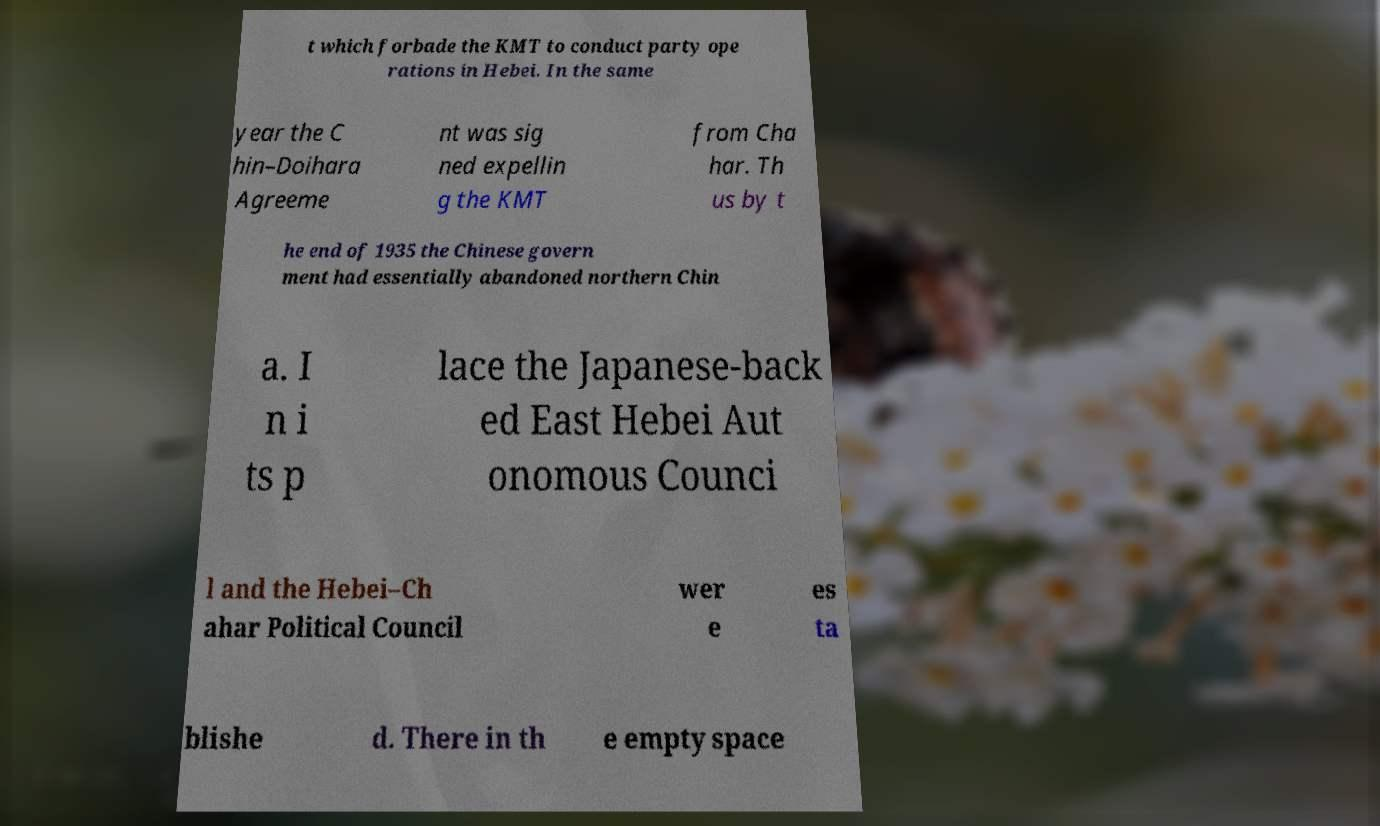Could you assist in decoding the text presented in this image and type it out clearly? t which forbade the KMT to conduct party ope rations in Hebei. In the same year the C hin–Doihara Agreeme nt was sig ned expellin g the KMT from Cha har. Th us by t he end of 1935 the Chinese govern ment had essentially abandoned northern Chin a. I n i ts p lace the Japanese-back ed East Hebei Aut onomous Counci l and the Hebei–Ch ahar Political Council wer e es ta blishe d. There in th e empty space 